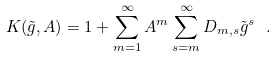<formula> <loc_0><loc_0><loc_500><loc_500>K ( \tilde { g } , A ) = 1 + \sum _ { m = 1 } ^ { \infty } A ^ { m } \sum _ { s = m } ^ { \infty } D _ { m , s } \tilde { g } ^ { s } \ .</formula> 